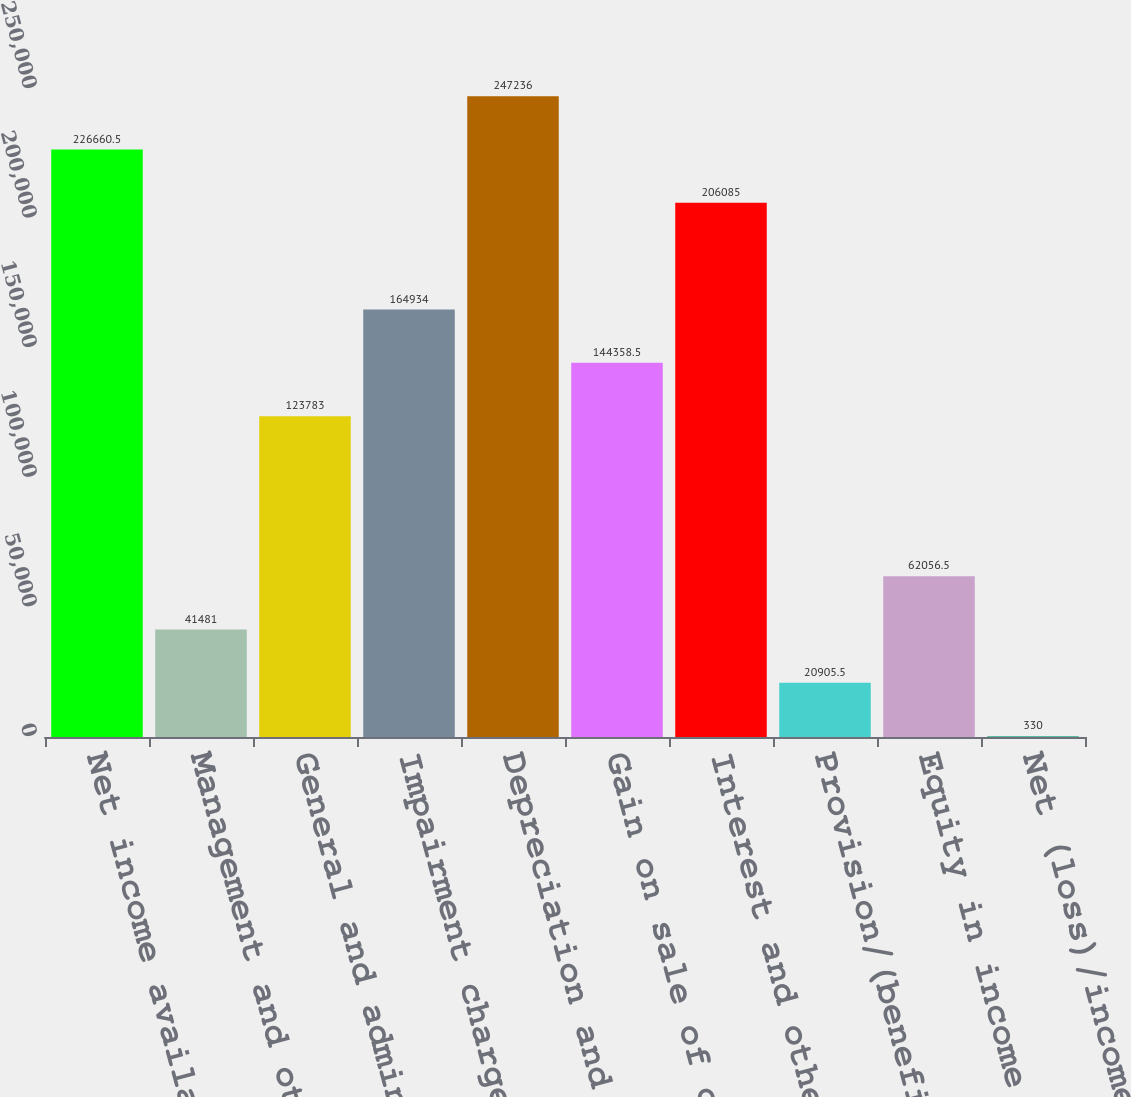Convert chart. <chart><loc_0><loc_0><loc_500><loc_500><bar_chart><fcel>Net income available to the<fcel>Management and other fee<fcel>General and administrative<fcel>Impairment charges<fcel>Depreciation and amortization<fcel>Gain on sale of operating<fcel>Interest and other expense net<fcel>Provision/(benefit) for income<fcel>Equity in income of other real<fcel>Net (loss)/income attributable<nl><fcel>226660<fcel>41481<fcel>123783<fcel>164934<fcel>247236<fcel>144358<fcel>206085<fcel>20905.5<fcel>62056.5<fcel>330<nl></chart> 